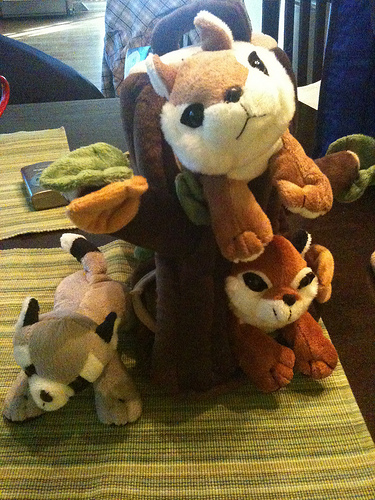<image>
Is there a squirrel above the squirrel? Yes. The squirrel is positioned above the squirrel in the vertical space, higher up in the scene. 